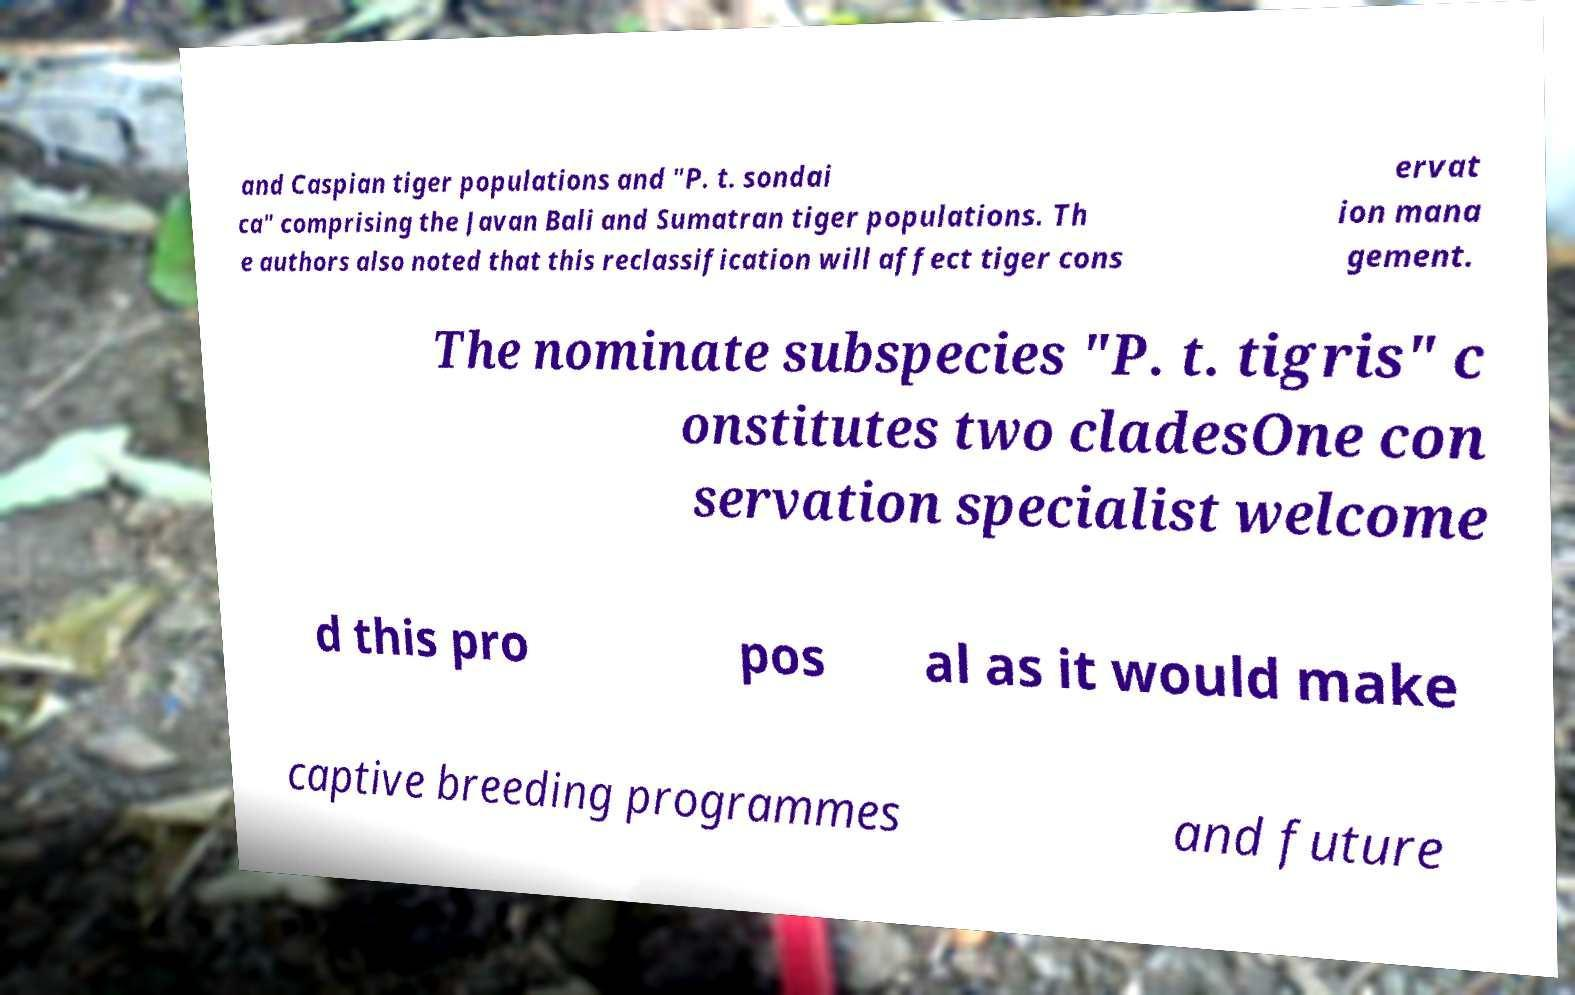Can you read and provide the text displayed in the image?This photo seems to have some interesting text. Can you extract and type it out for me? and Caspian tiger populations and "P. t. sondai ca" comprising the Javan Bali and Sumatran tiger populations. Th e authors also noted that this reclassification will affect tiger cons ervat ion mana gement. The nominate subspecies "P. t. tigris" c onstitutes two cladesOne con servation specialist welcome d this pro pos al as it would make captive breeding programmes and future 